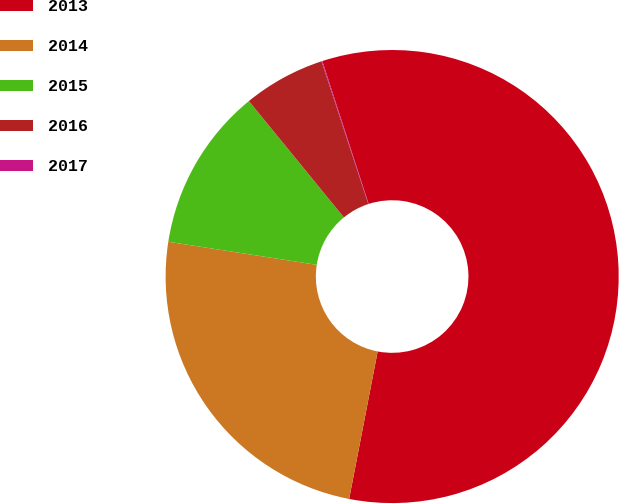Convert chart. <chart><loc_0><loc_0><loc_500><loc_500><pie_chart><fcel>2013<fcel>2014<fcel>2015<fcel>2016<fcel>2017<nl><fcel>58.02%<fcel>24.41%<fcel>11.65%<fcel>5.85%<fcel>0.06%<nl></chart> 